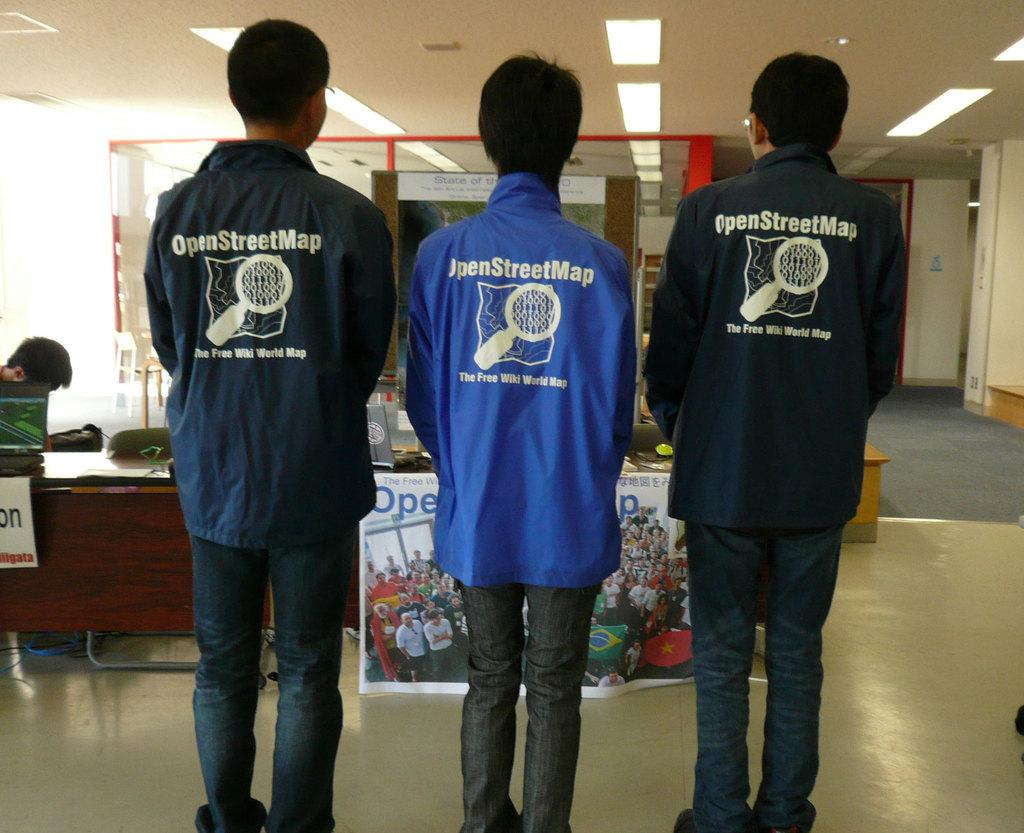<image>
Relay a brief, clear account of the picture shown. Three men standing, each wearing a jacket for Open Street Map. 